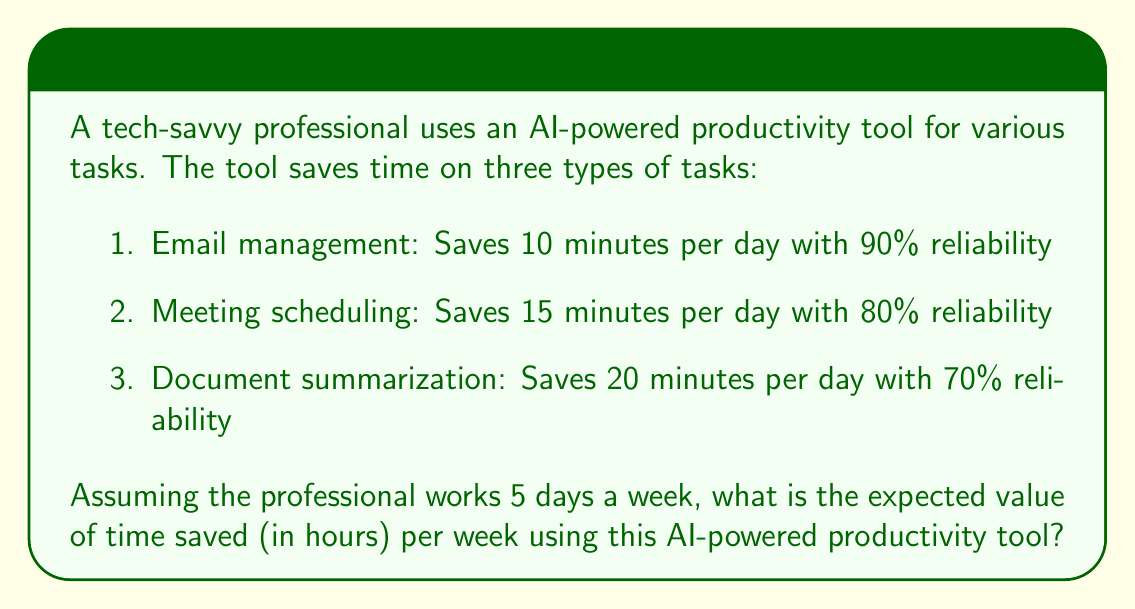Solve this math problem. Let's approach this step-by-step:

1. Calculate the expected time saved for each task per day:

   a. Email management:
      $E(\text{email}) = 10 \text{ minutes} \times 0.90 = 9 \text{ minutes}$

   b. Meeting scheduling:
      $E(\text{meeting}) = 15 \text{ minutes} \times 0.80 = 12 \text{ minutes}$

   c. Document summarization:
      $E(\text{document}) = 20 \text{ minutes} \times 0.70 = 14 \text{ minutes}$

2. Sum up the expected time saved per day:
   $$E(\text{total per day}) = 9 + 12 + 14 = 35 \text{ minutes}$$

3. Calculate the expected time saved per week (5 working days):
   $$E(\text{total per week}) = 35 \text{ minutes} \times 5 \text{ days} = 175 \text{ minutes}$$

4. Convert minutes to hours:
   $$E(\text{total per week in hours}) = \frac{175 \text{ minutes}}{60 \text{ minutes/hour}} = 2.916666... \text{ hours}$$

Thus, the expected value of time saved per week is approximately 2.92 hours.
Answer: 2.92 hours 